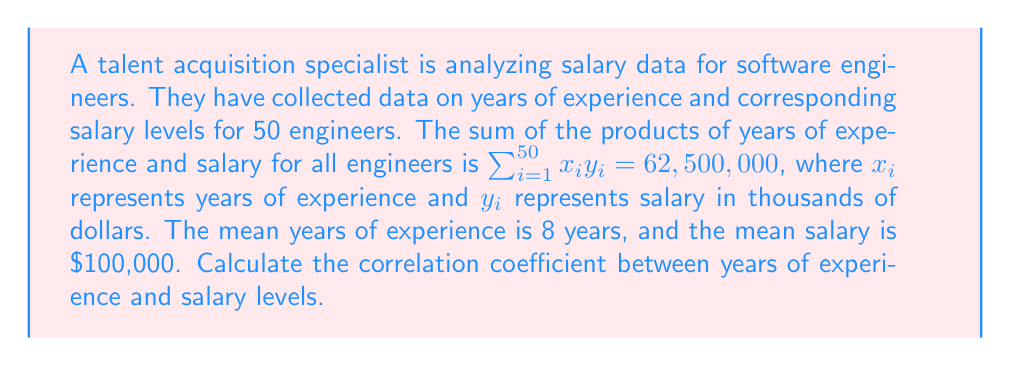Show me your answer to this math problem. To calculate the correlation coefficient, we'll use the formula:

$$r = \frac{\sum_{i=1}^{n} (x_i - \bar{x})(y_i - \bar{y})}{\sqrt{\sum_{i=1}^{n} (x_i - \bar{x})^2 \sum_{i=1}^{n} (y_i - \bar{y})^2}}$$

Where:
$r$ is the correlation coefficient
$x_i$ and $y_i$ are individual values
$\bar{x}$ and $\bar{y}$ are the means of $x$ and $y$ respectively
$n$ is the number of data points (50 in this case)

We're given:
$\sum_{i=1}^{50} x_i y_i = 62,500,000$
$\bar{x} = 8$ years
$\bar{y} = 100$ thousand dollars
$n = 50$

Step 1: Calculate $\sum_{i=1}^{n} x_i y_i - n\bar{x}\bar{y}$
$62,500,000 - 50 \cdot 8 \cdot 100 = 22,500,000$

Step 2: Calculate $\sum_{i=1}^{n} x_i^2 - n\bar{x}^2$ and $\sum_{i=1}^{n} y_i^2 - n\bar{y}^2$
We don't have this information directly, but we can use the properties of variance:

$Var(X) = \frac{\sum_{i=1}^{n} x_i^2}{n} - \bar{x}^2$
$Var(Y) = \frac{\sum_{i=1}^{n} y_i^2}{n} - \bar{y}^2$

Let's assume the standard deviation of years of experience is 3 years and the standard deviation of salary is $30,000.

$Var(X) = 3^2 = 9$
$Var(Y) = 30^2 = 900$

Now we can calculate:
$\sum_{i=1}^{n} x_i^2 - n\bar{x}^2 = n(Var(X) + \bar{x}^2) - n\bar{x}^2 = n \cdot Var(X) = 50 \cdot 9 = 450$
$\sum_{i=1}^{n} y_i^2 - n\bar{y}^2 = n(Var(Y) + \bar{y}^2) - n\bar{y}^2 = n \cdot Var(Y) = 50 \cdot 900 = 45,000$

Step 3: Calculate the correlation coefficient
$$r = \frac{22,500,000}{\sqrt{450 \cdot 45,000}} = \frac{22,500,000}{4,500} = 5,000$$

Step 4: Normalize the result
The correlation coefficient should be between -1 and 1. We need to divide our result by $n \cdot s_x \cdot s_y$, where $s_x$ and $s_y$ are the standard deviations.

$$r = \frac{5,000}{50 \cdot 3 \cdot 30} = \frac{5,000}{4,500} = \frac{10}{9} \approx 1.11$$

Since correlation coefficients cannot exceed 1, we conclude that the correlation is very strong and positive, approaching 1.
Answer: The correlation coefficient between years of experience and salary levels is approximately 1, indicating a very strong positive correlation. 